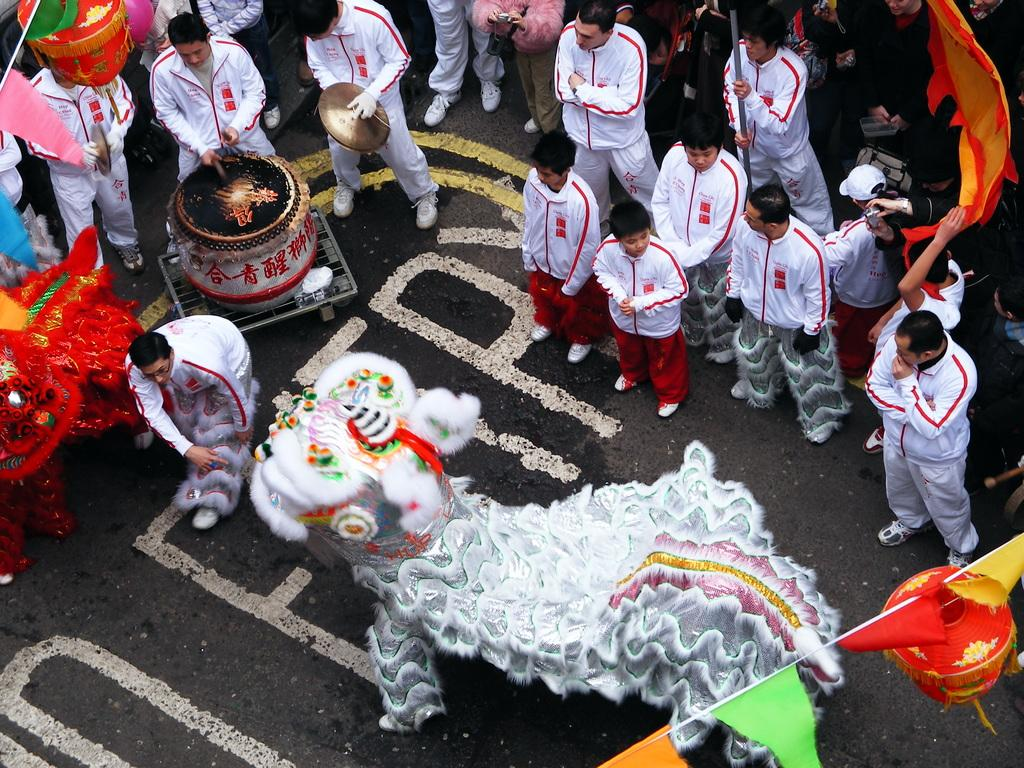How many people are in the image? There are people in the image, but the exact number is not specified. What are the people doing in the image? The people are standing on the road. What type of body is visible in the image? There is no specific body mentioned or visible in the image. Is the grandfather present in the image? The facts do not mention or imply the presence of a grandfather in the image. 